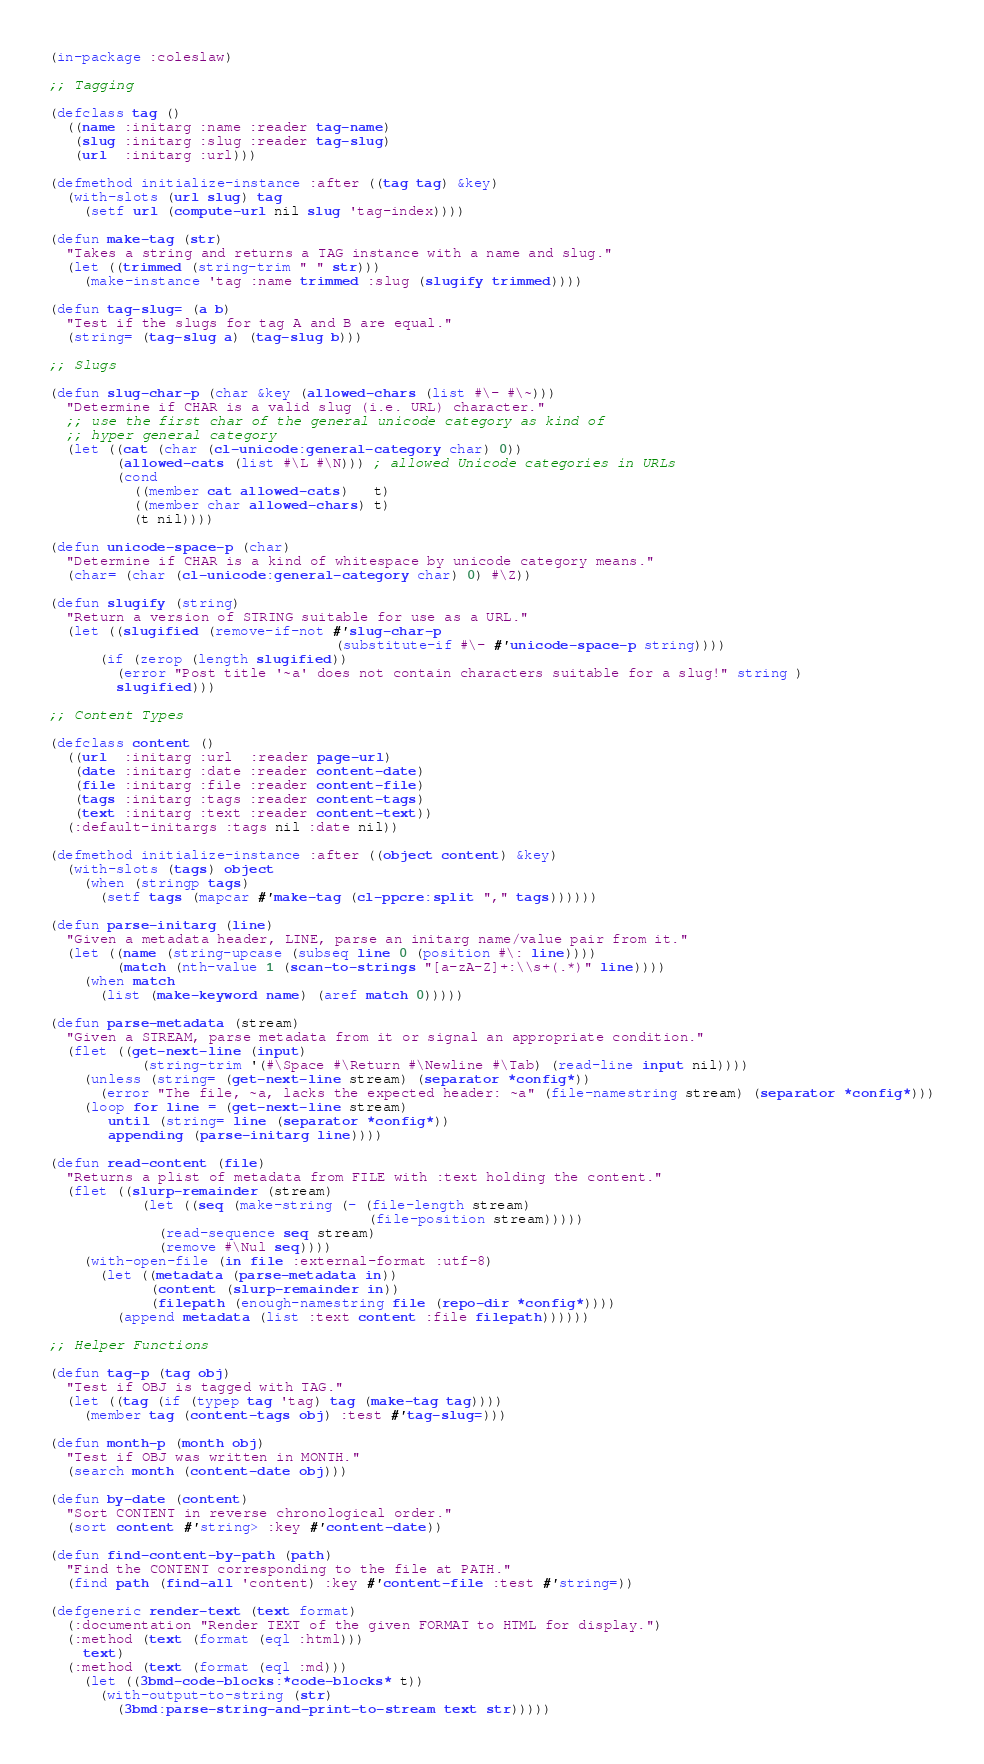<code> <loc_0><loc_0><loc_500><loc_500><_Lisp_>(in-package :coleslaw)

;; Tagging

(defclass tag ()
  ((name :initarg :name :reader tag-name)
   (slug :initarg :slug :reader tag-slug)
   (url  :initarg :url)))

(defmethod initialize-instance :after ((tag tag) &key)
  (with-slots (url slug) tag
    (setf url (compute-url nil slug 'tag-index))))

(defun make-tag (str)
  "Takes a string and returns a TAG instance with a name and slug."
  (let ((trimmed (string-trim " " str)))
    (make-instance 'tag :name trimmed :slug (slugify trimmed))))

(defun tag-slug= (a b)
  "Test if the slugs for tag A and B are equal."
  (string= (tag-slug a) (tag-slug b)))

;; Slugs

(defun slug-char-p (char &key (allowed-chars (list #\- #\~)))
  "Determine if CHAR is a valid slug (i.e. URL) character."
  ;; use the first char of the general unicode category as kind of
  ;; hyper general category
  (let ((cat (char (cl-unicode:general-category char) 0))
        (allowed-cats (list #\L #\N))) ; allowed Unicode categories in URLs
        (cond
          ((member cat allowed-cats)   t)
          ((member char allowed-chars) t)
          (t nil))))

(defun unicode-space-p (char)
  "Determine if CHAR is a kind of whitespace by unicode category means."
  (char= (char (cl-unicode:general-category char) 0) #\Z))

(defun slugify (string)
  "Return a version of STRING suitable for use as a URL."
  (let ((slugified (remove-if-not #'slug-char-p
                                  (substitute-if #\- #'unicode-space-p string))))
	  (if (zerop (length slugified))
        (error "Post title '~a' does not contain characters suitable for a slug!" string )
        slugified)))

;; Content Types

(defclass content ()
  ((url  :initarg :url  :reader page-url)
   (date :initarg :date :reader content-date)
   (file :initarg :file :reader content-file)
   (tags :initarg :tags :reader content-tags)
   (text :initarg :text :reader content-text))
  (:default-initargs :tags nil :date nil))

(defmethod initialize-instance :after ((object content) &key)
  (with-slots (tags) object
    (when (stringp tags)
      (setf tags (mapcar #'make-tag (cl-ppcre:split "," tags))))))

(defun parse-initarg (line)
  "Given a metadata header, LINE, parse an initarg name/value pair from it."
  (let ((name (string-upcase (subseq line 0 (position #\: line))))
        (match (nth-value 1 (scan-to-strings "[a-zA-Z]+:\\s+(.*)" line))))
    (when match
      (list (make-keyword name) (aref match 0)))))

(defun parse-metadata (stream)
  "Given a STREAM, parse metadata from it or signal an appropriate condition."
  (flet ((get-next-line (input)
           (string-trim '(#\Space #\Return #\Newline #\Tab) (read-line input nil))))
    (unless (string= (get-next-line stream) (separator *config*))
      (error "The file, ~a, lacks the expected header: ~a" (file-namestring stream) (separator *config*)))
    (loop for line = (get-next-line stream)
       until (string= line (separator *config*))
       appending (parse-initarg line))))

(defun read-content (file)
  "Returns a plist of metadata from FILE with :text holding the content."
  (flet ((slurp-remainder (stream)
           (let ((seq (make-string (- (file-length stream)
                                      (file-position stream)))))
             (read-sequence seq stream)
             (remove #\Nul seq))))
    (with-open-file (in file :external-format :utf-8)
      (let ((metadata (parse-metadata in))
            (content (slurp-remainder in))
            (filepath (enough-namestring file (repo-dir *config*))))
        (append metadata (list :text content :file filepath))))))

;; Helper Functions

(defun tag-p (tag obj)
  "Test if OBJ is tagged with TAG."
  (let ((tag (if (typep tag 'tag) tag (make-tag tag))))
    (member tag (content-tags obj) :test #'tag-slug=)))

(defun month-p (month obj)
  "Test if OBJ was written in MONTH."
  (search month (content-date obj)))

(defun by-date (content)
  "Sort CONTENT in reverse chronological order."
  (sort content #'string> :key #'content-date))

(defun find-content-by-path (path)
  "Find the CONTENT corresponding to the file at PATH."
  (find path (find-all 'content) :key #'content-file :test #'string=))

(defgeneric render-text (text format)
  (:documentation "Render TEXT of the given FORMAT to HTML for display.")
  (:method (text (format (eql :html)))
    text)
  (:method (text (format (eql :md)))
    (let ((3bmd-code-blocks:*code-blocks* t))
      (with-output-to-string (str)
        (3bmd:parse-string-and-print-to-stream text str)))))
</code> 